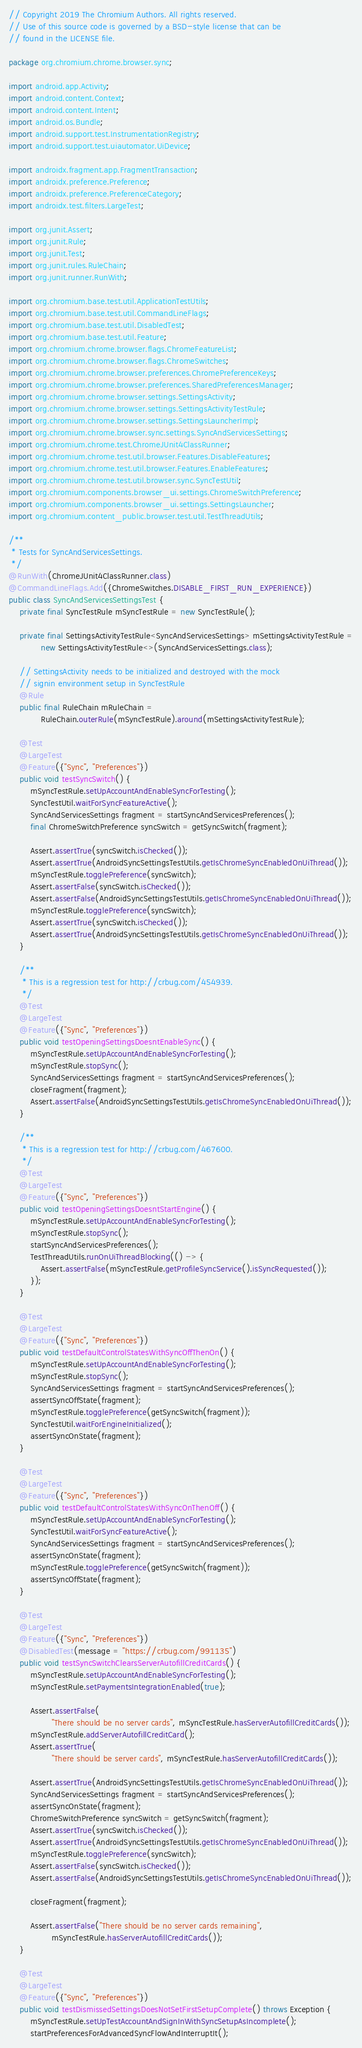<code> <loc_0><loc_0><loc_500><loc_500><_Java_>// Copyright 2019 The Chromium Authors. All rights reserved.
// Use of this source code is governed by a BSD-style license that can be
// found in the LICENSE file.

package org.chromium.chrome.browser.sync;

import android.app.Activity;
import android.content.Context;
import android.content.Intent;
import android.os.Bundle;
import android.support.test.InstrumentationRegistry;
import android.support.test.uiautomator.UiDevice;

import androidx.fragment.app.FragmentTransaction;
import androidx.preference.Preference;
import androidx.preference.PreferenceCategory;
import androidx.test.filters.LargeTest;

import org.junit.Assert;
import org.junit.Rule;
import org.junit.Test;
import org.junit.rules.RuleChain;
import org.junit.runner.RunWith;

import org.chromium.base.test.util.ApplicationTestUtils;
import org.chromium.base.test.util.CommandLineFlags;
import org.chromium.base.test.util.DisabledTest;
import org.chromium.base.test.util.Feature;
import org.chromium.chrome.browser.flags.ChromeFeatureList;
import org.chromium.chrome.browser.flags.ChromeSwitches;
import org.chromium.chrome.browser.preferences.ChromePreferenceKeys;
import org.chromium.chrome.browser.preferences.SharedPreferencesManager;
import org.chromium.chrome.browser.settings.SettingsActivity;
import org.chromium.chrome.browser.settings.SettingsActivityTestRule;
import org.chromium.chrome.browser.settings.SettingsLauncherImpl;
import org.chromium.chrome.browser.sync.settings.SyncAndServicesSettings;
import org.chromium.chrome.test.ChromeJUnit4ClassRunner;
import org.chromium.chrome.test.util.browser.Features.DisableFeatures;
import org.chromium.chrome.test.util.browser.Features.EnableFeatures;
import org.chromium.chrome.test.util.browser.sync.SyncTestUtil;
import org.chromium.components.browser_ui.settings.ChromeSwitchPreference;
import org.chromium.components.browser_ui.settings.SettingsLauncher;
import org.chromium.content_public.browser.test.util.TestThreadUtils;

/**
 * Tests for SyncAndServicesSettings.
 */
@RunWith(ChromeJUnit4ClassRunner.class)
@CommandLineFlags.Add({ChromeSwitches.DISABLE_FIRST_RUN_EXPERIENCE})
public class SyncAndServicesSettingsTest {
    private final SyncTestRule mSyncTestRule = new SyncTestRule();

    private final SettingsActivityTestRule<SyncAndServicesSettings> mSettingsActivityTestRule =
            new SettingsActivityTestRule<>(SyncAndServicesSettings.class);

    // SettingsActivity needs to be initialized and destroyed with the mock
    // signin environment setup in SyncTestRule
    @Rule
    public final RuleChain mRuleChain =
            RuleChain.outerRule(mSyncTestRule).around(mSettingsActivityTestRule);

    @Test
    @LargeTest
    @Feature({"Sync", "Preferences"})
    public void testSyncSwitch() {
        mSyncTestRule.setUpAccountAndEnableSyncForTesting();
        SyncTestUtil.waitForSyncFeatureActive();
        SyncAndServicesSettings fragment = startSyncAndServicesPreferences();
        final ChromeSwitchPreference syncSwitch = getSyncSwitch(fragment);

        Assert.assertTrue(syncSwitch.isChecked());
        Assert.assertTrue(AndroidSyncSettingsTestUtils.getIsChromeSyncEnabledOnUiThread());
        mSyncTestRule.togglePreference(syncSwitch);
        Assert.assertFalse(syncSwitch.isChecked());
        Assert.assertFalse(AndroidSyncSettingsTestUtils.getIsChromeSyncEnabledOnUiThread());
        mSyncTestRule.togglePreference(syncSwitch);
        Assert.assertTrue(syncSwitch.isChecked());
        Assert.assertTrue(AndroidSyncSettingsTestUtils.getIsChromeSyncEnabledOnUiThread());
    }

    /**
     * This is a regression test for http://crbug.com/454939.
     */
    @Test
    @LargeTest
    @Feature({"Sync", "Preferences"})
    public void testOpeningSettingsDoesntEnableSync() {
        mSyncTestRule.setUpAccountAndEnableSyncForTesting();
        mSyncTestRule.stopSync();
        SyncAndServicesSettings fragment = startSyncAndServicesPreferences();
        closeFragment(fragment);
        Assert.assertFalse(AndroidSyncSettingsTestUtils.getIsChromeSyncEnabledOnUiThread());
    }

    /**
     * This is a regression test for http://crbug.com/467600.
     */
    @Test
    @LargeTest
    @Feature({"Sync", "Preferences"})
    public void testOpeningSettingsDoesntStartEngine() {
        mSyncTestRule.setUpAccountAndEnableSyncForTesting();
        mSyncTestRule.stopSync();
        startSyncAndServicesPreferences();
        TestThreadUtils.runOnUiThreadBlocking(() -> {
            Assert.assertFalse(mSyncTestRule.getProfileSyncService().isSyncRequested());
        });
    }

    @Test
    @LargeTest
    @Feature({"Sync", "Preferences"})
    public void testDefaultControlStatesWithSyncOffThenOn() {
        mSyncTestRule.setUpAccountAndEnableSyncForTesting();
        mSyncTestRule.stopSync();
        SyncAndServicesSettings fragment = startSyncAndServicesPreferences();
        assertSyncOffState(fragment);
        mSyncTestRule.togglePreference(getSyncSwitch(fragment));
        SyncTestUtil.waitForEngineInitialized();
        assertSyncOnState(fragment);
    }

    @Test
    @LargeTest
    @Feature({"Sync", "Preferences"})
    public void testDefaultControlStatesWithSyncOnThenOff() {
        mSyncTestRule.setUpAccountAndEnableSyncForTesting();
        SyncTestUtil.waitForSyncFeatureActive();
        SyncAndServicesSettings fragment = startSyncAndServicesPreferences();
        assertSyncOnState(fragment);
        mSyncTestRule.togglePreference(getSyncSwitch(fragment));
        assertSyncOffState(fragment);
    }

    @Test
    @LargeTest
    @Feature({"Sync", "Preferences"})
    @DisabledTest(message = "https://crbug.com/991135")
    public void testSyncSwitchClearsServerAutofillCreditCards() {
        mSyncTestRule.setUpAccountAndEnableSyncForTesting();
        mSyncTestRule.setPaymentsIntegrationEnabled(true);

        Assert.assertFalse(
                "There should be no server cards", mSyncTestRule.hasServerAutofillCreditCards());
        mSyncTestRule.addServerAutofillCreditCard();
        Assert.assertTrue(
                "There should be server cards", mSyncTestRule.hasServerAutofillCreditCards());

        Assert.assertTrue(AndroidSyncSettingsTestUtils.getIsChromeSyncEnabledOnUiThread());
        SyncAndServicesSettings fragment = startSyncAndServicesPreferences();
        assertSyncOnState(fragment);
        ChromeSwitchPreference syncSwitch = getSyncSwitch(fragment);
        Assert.assertTrue(syncSwitch.isChecked());
        Assert.assertTrue(AndroidSyncSettingsTestUtils.getIsChromeSyncEnabledOnUiThread());
        mSyncTestRule.togglePreference(syncSwitch);
        Assert.assertFalse(syncSwitch.isChecked());
        Assert.assertFalse(AndroidSyncSettingsTestUtils.getIsChromeSyncEnabledOnUiThread());

        closeFragment(fragment);

        Assert.assertFalse("There should be no server cards remaining",
                mSyncTestRule.hasServerAutofillCreditCards());
    }

    @Test
    @LargeTest
    @Feature({"Sync", "Preferences"})
    public void testDismissedSettingsDoesNotSetFirstSetupComplete() throws Exception {
        mSyncTestRule.setUpTestAccountAndSignInWithSyncSetupAsIncomplete();
        startPreferencesForAdvancedSyncFlowAndInterruptIt();</code> 